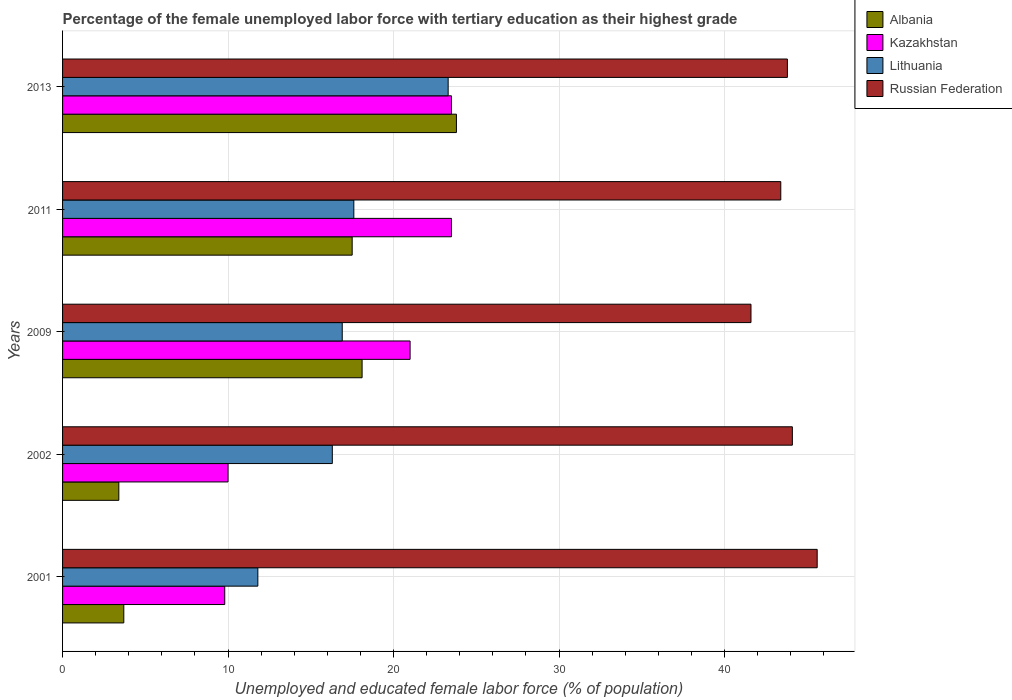How many groups of bars are there?
Offer a terse response. 5. Are the number of bars on each tick of the Y-axis equal?
Keep it short and to the point. Yes. How many bars are there on the 2nd tick from the top?
Provide a short and direct response. 4. In how many cases, is the number of bars for a given year not equal to the number of legend labels?
Your response must be concise. 0. What is the percentage of the unemployed female labor force with tertiary education in Russian Federation in 2002?
Provide a succinct answer. 44.1. Across all years, what is the minimum percentage of the unemployed female labor force with tertiary education in Albania?
Give a very brief answer. 3.4. In which year was the percentage of the unemployed female labor force with tertiary education in Russian Federation maximum?
Provide a succinct answer. 2001. What is the total percentage of the unemployed female labor force with tertiary education in Kazakhstan in the graph?
Offer a very short reply. 87.8. What is the difference between the percentage of the unemployed female labor force with tertiary education in Russian Federation in 2002 and that in 2013?
Offer a very short reply. 0.3. What is the difference between the percentage of the unemployed female labor force with tertiary education in Kazakhstan in 2009 and the percentage of the unemployed female labor force with tertiary education in Russian Federation in 2013?
Offer a very short reply. -22.8. What is the average percentage of the unemployed female labor force with tertiary education in Kazakhstan per year?
Your response must be concise. 17.56. In the year 2002, what is the difference between the percentage of the unemployed female labor force with tertiary education in Kazakhstan and percentage of the unemployed female labor force with tertiary education in Lithuania?
Offer a terse response. -6.3. What is the ratio of the percentage of the unemployed female labor force with tertiary education in Kazakhstan in 2001 to that in 2009?
Make the answer very short. 0.47. Is the difference between the percentage of the unemployed female labor force with tertiary education in Kazakhstan in 2002 and 2011 greater than the difference between the percentage of the unemployed female labor force with tertiary education in Lithuania in 2002 and 2011?
Provide a short and direct response. No. What is the difference between the highest and the second highest percentage of the unemployed female labor force with tertiary education in Albania?
Your answer should be compact. 5.7. What is the difference between the highest and the lowest percentage of the unemployed female labor force with tertiary education in Kazakhstan?
Your response must be concise. 13.7. In how many years, is the percentage of the unemployed female labor force with tertiary education in Lithuania greater than the average percentage of the unemployed female labor force with tertiary education in Lithuania taken over all years?
Provide a succinct answer. 2. Is the sum of the percentage of the unemployed female labor force with tertiary education in Albania in 2002 and 2009 greater than the maximum percentage of the unemployed female labor force with tertiary education in Kazakhstan across all years?
Your response must be concise. No. Is it the case that in every year, the sum of the percentage of the unemployed female labor force with tertiary education in Lithuania and percentage of the unemployed female labor force with tertiary education in Russian Federation is greater than the sum of percentage of the unemployed female labor force with tertiary education in Kazakhstan and percentage of the unemployed female labor force with tertiary education in Albania?
Keep it short and to the point. Yes. What does the 2nd bar from the top in 2002 represents?
Your answer should be compact. Lithuania. What does the 2nd bar from the bottom in 2013 represents?
Give a very brief answer. Kazakhstan. What is the difference between two consecutive major ticks on the X-axis?
Provide a short and direct response. 10. Where does the legend appear in the graph?
Keep it short and to the point. Top right. What is the title of the graph?
Ensure brevity in your answer.  Percentage of the female unemployed labor force with tertiary education as their highest grade. What is the label or title of the X-axis?
Your answer should be compact. Unemployed and educated female labor force (% of population). What is the Unemployed and educated female labor force (% of population) in Albania in 2001?
Your answer should be very brief. 3.7. What is the Unemployed and educated female labor force (% of population) of Kazakhstan in 2001?
Provide a succinct answer. 9.8. What is the Unemployed and educated female labor force (% of population) in Lithuania in 2001?
Offer a terse response. 11.8. What is the Unemployed and educated female labor force (% of population) in Russian Federation in 2001?
Provide a succinct answer. 45.6. What is the Unemployed and educated female labor force (% of population) of Albania in 2002?
Make the answer very short. 3.4. What is the Unemployed and educated female labor force (% of population) of Lithuania in 2002?
Provide a succinct answer. 16.3. What is the Unemployed and educated female labor force (% of population) of Russian Federation in 2002?
Make the answer very short. 44.1. What is the Unemployed and educated female labor force (% of population) in Albania in 2009?
Give a very brief answer. 18.1. What is the Unemployed and educated female labor force (% of population) of Kazakhstan in 2009?
Your response must be concise. 21. What is the Unemployed and educated female labor force (% of population) of Lithuania in 2009?
Your answer should be very brief. 16.9. What is the Unemployed and educated female labor force (% of population) of Russian Federation in 2009?
Provide a short and direct response. 41.6. What is the Unemployed and educated female labor force (% of population) in Albania in 2011?
Your answer should be very brief. 17.5. What is the Unemployed and educated female labor force (% of population) in Lithuania in 2011?
Offer a terse response. 17.6. What is the Unemployed and educated female labor force (% of population) of Russian Federation in 2011?
Provide a succinct answer. 43.4. What is the Unemployed and educated female labor force (% of population) of Albania in 2013?
Ensure brevity in your answer.  23.8. What is the Unemployed and educated female labor force (% of population) of Lithuania in 2013?
Ensure brevity in your answer.  23.3. What is the Unemployed and educated female labor force (% of population) of Russian Federation in 2013?
Your answer should be compact. 43.8. Across all years, what is the maximum Unemployed and educated female labor force (% of population) in Albania?
Offer a very short reply. 23.8. Across all years, what is the maximum Unemployed and educated female labor force (% of population) in Lithuania?
Provide a short and direct response. 23.3. Across all years, what is the maximum Unemployed and educated female labor force (% of population) in Russian Federation?
Offer a terse response. 45.6. Across all years, what is the minimum Unemployed and educated female labor force (% of population) of Albania?
Keep it short and to the point. 3.4. Across all years, what is the minimum Unemployed and educated female labor force (% of population) of Kazakhstan?
Your response must be concise. 9.8. Across all years, what is the minimum Unemployed and educated female labor force (% of population) of Lithuania?
Your response must be concise. 11.8. Across all years, what is the minimum Unemployed and educated female labor force (% of population) in Russian Federation?
Provide a short and direct response. 41.6. What is the total Unemployed and educated female labor force (% of population) in Albania in the graph?
Make the answer very short. 66.5. What is the total Unemployed and educated female labor force (% of population) of Kazakhstan in the graph?
Your answer should be compact. 87.8. What is the total Unemployed and educated female labor force (% of population) of Lithuania in the graph?
Provide a short and direct response. 85.9. What is the total Unemployed and educated female labor force (% of population) of Russian Federation in the graph?
Your response must be concise. 218.5. What is the difference between the Unemployed and educated female labor force (% of population) in Albania in 2001 and that in 2002?
Provide a short and direct response. 0.3. What is the difference between the Unemployed and educated female labor force (% of population) of Kazakhstan in 2001 and that in 2002?
Provide a succinct answer. -0.2. What is the difference between the Unemployed and educated female labor force (% of population) of Albania in 2001 and that in 2009?
Give a very brief answer. -14.4. What is the difference between the Unemployed and educated female labor force (% of population) of Kazakhstan in 2001 and that in 2009?
Keep it short and to the point. -11.2. What is the difference between the Unemployed and educated female labor force (% of population) in Lithuania in 2001 and that in 2009?
Your answer should be very brief. -5.1. What is the difference between the Unemployed and educated female labor force (% of population) in Russian Federation in 2001 and that in 2009?
Make the answer very short. 4. What is the difference between the Unemployed and educated female labor force (% of population) of Kazakhstan in 2001 and that in 2011?
Your response must be concise. -13.7. What is the difference between the Unemployed and educated female labor force (% of population) in Lithuania in 2001 and that in 2011?
Your answer should be compact. -5.8. What is the difference between the Unemployed and educated female labor force (% of population) of Albania in 2001 and that in 2013?
Your answer should be compact. -20.1. What is the difference between the Unemployed and educated female labor force (% of population) of Kazakhstan in 2001 and that in 2013?
Your response must be concise. -13.7. What is the difference between the Unemployed and educated female labor force (% of population) in Lithuania in 2001 and that in 2013?
Your answer should be compact. -11.5. What is the difference between the Unemployed and educated female labor force (% of population) of Albania in 2002 and that in 2009?
Your answer should be very brief. -14.7. What is the difference between the Unemployed and educated female labor force (% of population) in Russian Federation in 2002 and that in 2009?
Ensure brevity in your answer.  2.5. What is the difference between the Unemployed and educated female labor force (% of population) in Albania in 2002 and that in 2011?
Your answer should be very brief. -14.1. What is the difference between the Unemployed and educated female labor force (% of population) in Russian Federation in 2002 and that in 2011?
Your answer should be compact. 0.7. What is the difference between the Unemployed and educated female labor force (% of population) in Albania in 2002 and that in 2013?
Ensure brevity in your answer.  -20.4. What is the difference between the Unemployed and educated female labor force (% of population) in Kazakhstan in 2002 and that in 2013?
Your answer should be compact. -13.5. What is the difference between the Unemployed and educated female labor force (% of population) in Lithuania in 2002 and that in 2013?
Keep it short and to the point. -7. What is the difference between the Unemployed and educated female labor force (% of population) of Albania in 2009 and that in 2011?
Provide a short and direct response. 0.6. What is the difference between the Unemployed and educated female labor force (% of population) in Kazakhstan in 2009 and that in 2011?
Your answer should be compact. -2.5. What is the difference between the Unemployed and educated female labor force (% of population) of Lithuania in 2009 and that in 2011?
Your response must be concise. -0.7. What is the difference between the Unemployed and educated female labor force (% of population) of Albania in 2009 and that in 2013?
Offer a very short reply. -5.7. What is the difference between the Unemployed and educated female labor force (% of population) of Kazakhstan in 2009 and that in 2013?
Ensure brevity in your answer.  -2.5. What is the difference between the Unemployed and educated female labor force (% of population) of Lithuania in 2009 and that in 2013?
Offer a terse response. -6.4. What is the difference between the Unemployed and educated female labor force (% of population) in Russian Federation in 2009 and that in 2013?
Offer a terse response. -2.2. What is the difference between the Unemployed and educated female labor force (% of population) in Russian Federation in 2011 and that in 2013?
Keep it short and to the point. -0.4. What is the difference between the Unemployed and educated female labor force (% of population) in Albania in 2001 and the Unemployed and educated female labor force (% of population) in Russian Federation in 2002?
Ensure brevity in your answer.  -40.4. What is the difference between the Unemployed and educated female labor force (% of population) in Kazakhstan in 2001 and the Unemployed and educated female labor force (% of population) in Russian Federation in 2002?
Provide a short and direct response. -34.3. What is the difference between the Unemployed and educated female labor force (% of population) in Lithuania in 2001 and the Unemployed and educated female labor force (% of population) in Russian Federation in 2002?
Ensure brevity in your answer.  -32.3. What is the difference between the Unemployed and educated female labor force (% of population) in Albania in 2001 and the Unemployed and educated female labor force (% of population) in Kazakhstan in 2009?
Keep it short and to the point. -17.3. What is the difference between the Unemployed and educated female labor force (% of population) of Albania in 2001 and the Unemployed and educated female labor force (% of population) of Lithuania in 2009?
Keep it short and to the point. -13.2. What is the difference between the Unemployed and educated female labor force (% of population) of Albania in 2001 and the Unemployed and educated female labor force (% of population) of Russian Federation in 2009?
Give a very brief answer. -37.9. What is the difference between the Unemployed and educated female labor force (% of population) in Kazakhstan in 2001 and the Unemployed and educated female labor force (% of population) in Russian Federation in 2009?
Your response must be concise. -31.8. What is the difference between the Unemployed and educated female labor force (% of population) in Lithuania in 2001 and the Unemployed and educated female labor force (% of population) in Russian Federation in 2009?
Give a very brief answer. -29.8. What is the difference between the Unemployed and educated female labor force (% of population) of Albania in 2001 and the Unemployed and educated female labor force (% of population) of Kazakhstan in 2011?
Your response must be concise. -19.8. What is the difference between the Unemployed and educated female labor force (% of population) of Albania in 2001 and the Unemployed and educated female labor force (% of population) of Russian Federation in 2011?
Offer a very short reply. -39.7. What is the difference between the Unemployed and educated female labor force (% of population) in Kazakhstan in 2001 and the Unemployed and educated female labor force (% of population) in Russian Federation in 2011?
Your response must be concise. -33.6. What is the difference between the Unemployed and educated female labor force (% of population) in Lithuania in 2001 and the Unemployed and educated female labor force (% of population) in Russian Federation in 2011?
Your answer should be compact. -31.6. What is the difference between the Unemployed and educated female labor force (% of population) in Albania in 2001 and the Unemployed and educated female labor force (% of population) in Kazakhstan in 2013?
Give a very brief answer. -19.8. What is the difference between the Unemployed and educated female labor force (% of population) in Albania in 2001 and the Unemployed and educated female labor force (% of population) in Lithuania in 2013?
Ensure brevity in your answer.  -19.6. What is the difference between the Unemployed and educated female labor force (% of population) in Albania in 2001 and the Unemployed and educated female labor force (% of population) in Russian Federation in 2013?
Ensure brevity in your answer.  -40.1. What is the difference between the Unemployed and educated female labor force (% of population) in Kazakhstan in 2001 and the Unemployed and educated female labor force (% of population) in Lithuania in 2013?
Your answer should be compact. -13.5. What is the difference between the Unemployed and educated female labor force (% of population) in Kazakhstan in 2001 and the Unemployed and educated female labor force (% of population) in Russian Federation in 2013?
Provide a succinct answer. -34. What is the difference between the Unemployed and educated female labor force (% of population) in Lithuania in 2001 and the Unemployed and educated female labor force (% of population) in Russian Federation in 2013?
Provide a short and direct response. -32. What is the difference between the Unemployed and educated female labor force (% of population) of Albania in 2002 and the Unemployed and educated female labor force (% of population) of Kazakhstan in 2009?
Provide a succinct answer. -17.6. What is the difference between the Unemployed and educated female labor force (% of population) of Albania in 2002 and the Unemployed and educated female labor force (% of population) of Lithuania in 2009?
Offer a very short reply. -13.5. What is the difference between the Unemployed and educated female labor force (% of population) in Albania in 2002 and the Unemployed and educated female labor force (% of population) in Russian Federation in 2009?
Your answer should be compact. -38.2. What is the difference between the Unemployed and educated female labor force (% of population) in Kazakhstan in 2002 and the Unemployed and educated female labor force (% of population) in Russian Federation in 2009?
Offer a very short reply. -31.6. What is the difference between the Unemployed and educated female labor force (% of population) of Lithuania in 2002 and the Unemployed and educated female labor force (% of population) of Russian Federation in 2009?
Provide a succinct answer. -25.3. What is the difference between the Unemployed and educated female labor force (% of population) in Albania in 2002 and the Unemployed and educated female labor force (% of population) in Kazakhstan in 2011?
Keep it short and to the point. -20.1. What is the difference between the Unemployed and educated female labor force (% of population) of Albania in 2002 and the Unemployed and educated female labor force (% of population) of Lithuania in 2011?
Your answer should be compact. -14.2. What is the difference between the Unemployed and educated female labor force (% of population) of Kazakhstan in 2002 and the Unemployed and educated female labor force (% of population) of Lithuania in 2011?
Ensure brevity in your answer.  -7.6. What is the difference between the Unemployed and educated female labor force (% of population) of Kazakhstan in 2002 and the Unemployed and educated female labor force (% of population) of Russian Federation in 2011?
Give a very brief answer. -33.4. What is the difference between the Unemployed and educated female labor force (% of population) in Lithuania in 2002 and the Unemployed and educated female labor force (% of population) in Russian Federation in 2011?
Your answer should be very brief. -27.1. What is the difference between the Unemployed and educated female labor force (% of population) in Albania in 2002 and the Unemployed and educated female labor force (% of population) in Kazakhstan in 2013?
Give a very brief answer. -20.1. What is the difference between the Unemployed and educated female labor force (% of population) in Albania in 2002 and the Unemployed and educated female labor force (% of population) in Lithuania in 2013?
Your answer should be compact. -19.9. What is the difference between the Unemployed and educated female labor force (% of population) of Albania in 2002 and the Unemployed and educated female labor force (% of population) of Russian Federation in 2013?
Keep it short and to the point. -40.4. What is the difference between the Unemployed and educated female labor force (% of population) in Kazakhstan in 2002 and the Unemployed and educated female labor force (% of population) in Russian Federation in 2013?
Make the answer very short. -33.8. What is the difference between the Unemployed and educated female labor force (% of population) in Lithuania in 2002 and the Unemployed and educated female labor force (% of population) in Russian Federation in 2013?
Make the answer very short. -27.5. What is the difference between the Unemployed and educated female labor force (% of population) of Albania in 2009 and the Unemployed and educated female labor force (% of population) of Kazakhstan in 2011?
Give a very brief answer. -5.4. What is the difference between the Unemployed and educated female labor force (% of population) in Albania in 2009 and the Unemployed and educated female labor force (% of population) in Russian Federation in 2011?
Provide a short and direct response. -25.3. What is the difference between the Unemployed and educated female labor force (% of population) in Kazakhstan in 2009 and the Unemployed and educated female labor force (% of population) in Lithuania in 2011?
Provide a short and direct response. 3.4. What is the difference between the Unemployed and educated female labor force (% of population) of Kazakhstan in 2009 and the Unemployed and educated female labor force (% of population) of Russian Federation in 2011?
Keep it short and to the point. -22.4. What is the difference between the Unemployed and educated female labor force (% of population) of Lithuania in 2009 and the Unemployed and educated female labor force (% of population) of Russian Federation in 2011?
Provide a succinct answer. -26.5. What is the difference between the Unemployed and educated female labor force (% of population) of Albania in 2009 and the Unemployed and educated female labor force (% of population) of Kazakhstan in 2013?
Your answer should be compact. -5.4. What is the difference between the Unemployed and educated female labor force (% of population) of Albania in 2009 and the Unemployed and educated female labor force (% of population) of Russian Federation in 2013?
Provide a succinct answer. -25.7. What is the difference between the Unemployed and educated female labor force (% of population) in Kazakhstan in 2009 and the Unemployed and educated female labor force (% of population) in Russian Federation in 2013?
Make the answer very short. -22.8. What is the difference between the Unemployed and educated female labor force (% of population) in Lithuania in 2009 and the Unemployed and educated female labor force (% of population) in Russian Federation in 2013?
Your answer should be compact. -26.9. What is the difference between the Unemployed and educated female labor force (% of population) in Albania in 2011 and the Unemployed and educated female labor force (% of population) in Lithuania in 2013?
Your answer should be compact. -5.8. What is the difference between the Unemployed and educated female labor force (% of population) in Albania in 2011 and the Unemployed and educated female labor force (% of population) in Russian Federation in 2013?
Provide a succinct answer. -26.3. What is the difference between the Unemployed and educated female labor force (% of population) in Kazakhstan in 2011 and the Unemployed and educated female labor force (% of population) in Russian Federation in 2013?
Give a very brief answer. -20.3. What is the difference between the Unemployed and educated female labor force (% of population) of Lithuania in 2011 and the Unemployed and educated female labor force (% of population) of Russian Federation in 2013?
Give a very brief answer. -26.2. What is the average Unemployed and educated female labor force (% of population) in Kazakhstan per year?
Provide a succinct answer. 17.56. What is the average Unemployed and educated female labor force (% of population) in Lithuania per year?
Keep it short and to the point. 17.18. What is the average Unemployed and educated female labor force (% of population) in Russian Federation per year?
Ensure brevity in your answer.  43.7. In the year 2001, what is the difference between the Unemployed and educated female labor force (% of population) of Albania and Unemployed and educated female labor force (% of population) of Lithuania?
Provide a short and direct response. -8.1. In the year 2001, what is the difference between the Unemployed and educated female labor force (% of population) of Albania and Unemployed and educated female labor force (% of population) of Russian Federation?
Your answer should be very brief. -41.9. In the year 2001, what is the difference between the Unemployed and educated female labor force (% of population) in Kazakhstan and Unemployed and educated female labor force (% of population) in Russian Federation?
Your answer should be very brief. -35.8. In the year 2001, what is the difference between the Unemployed and educated female labor force (% of population) of Lithuania and Unemployed and educated female labor force (% of population) of Russian Federation?
Your answer should be very brief. -33.8. In the year 2002, what is the difference between the Unemployed and educated female labor force (% of population) of Albania and Unemployed and educated female labor force (% of population) of Russian Federation?
Ensure brevity in your answer.  -40.7. In the year 2002, what is the difference between the Unemployed and educated female labor force (% of population) of Kazakhstan and Unemployed and educated female labor force (% of population) of Russian Federation?
Make the answer very short. -34.1. In the year 2002, what is the difference between the Unemployed and educated female labor force (% of population) of Lithuania and Unemployed and educated female labor force (% of population) of Russian Federation?
Your answer should be very brief. -27.8. In the year 2009, what is the difference between the Unemployed and educated female labor force (% of population) of Albania and Unemployed and educated female labor force (% of population) of Kazakhstan?
Offer a very short reply. -2.9. In the year 2009, what is the difference between the Unemployed and educated female labor force (% of population) of Albania and Unemployed and educated female labor force (% of population) of Lithuania?
Your answer should be very brief. 1.2. In the year 2009, what is the difference between the Unemployed and educated female labor force (% of population) of Albania and Unemployed and educated female labor force (% of population) of Russian Federation?
Your response must be concise. -23.5. In the year 2009, what is the difference between the Unemployed and educated female labor force (% of population) of Kazakhstan and Unemployed and educated female labor force (% of population) of Russian Federation?
Your answer should be very brief. -20.6. In the year 2009, what is the difference between the Unemployed and educated female labor force (% of population) of Lithuania and Unemployed and educated female labor force (% of population) of Russian Federation?
Offer a terse response. -24.7. In the year 2011, what is the difference between the Unemployed and educated female labor force (% of population) of Albania and Unemployed and educated female labor force (% of population) of Kazakhstan?
Offer a very short reply. -6. In the year 2011, what is the difference between the Unemployed and educated female labor force (% of population) in Albania and Unemployed and educated female labor force (% of population) in Russian Federation?
Keep it short and to the point. -25.9. In the year 2011, what is the difference between the Unemployed and educated female labor force (% of population) in Kazakhstan and Unemployed and educated female labor force (% of population) in Lithuania?
Provide a succinct answer. 5.9. In the year 2011, what is the difference between the Unemployed and educated female labor force (% of population) in Kazakhstan and Unemployed and educated female labor force (% of population) in Russian Federation?
Your answer should be compact. -19.9. In the year 2011, what is the difference between the Unemployed and educated female labor force (% of population) of Lithuania and Unemployed and educated female labor force (% of population) of Russian Federation?
Keep it short and to the point. -25.8. In the year 2013, what is the difference between the Unemployed and educated female labor force (% of population) in Kazakhstan and Unemployed and educated female labor force (% of population) in Lithuania?
Offer a very short reply. 0.2. In the year 2013, what is the difference between the Unemployed and educated female labor force (% of population) in Kazakhstan and Unemployed and educated female labor force (% of population) in Russian Federation?
Give a very brief answer. -20.3. In the year 2013, what is the difference between the Unemployed and educated female labor force (% of population) in Lithuania and Unemployed and educated female labor force (% of population) in Russian Federation?
Ensure brevity in your answer.  -20.5. What is the ratio of the Unemployed and educated female labor force (% of population) in Albania in 2001 to that in 2002?
Offer a terse response. 1.09. What is the ratio of the Unemployed and educated female labor force (% of population) in Kazakhstan in 2001 to that in 2002?
Your answer should be very brief. 0.98. What is the ratio of the Unemployed and educated female labor force (% of population) in Lithuania in 2001 to that in 2002?
Make the answer very short. 0.72. What is the ratio of the Unemployed and educated female labor force (% of population) in Russian Federation in 2001 to that in 2002?
Offer a terse response. 1.03. What is the ratio of the Unemployed and educated female labor force (% of population) of Albania in 2001 to that in 2009?
Keep it short and to the point. 0.2. What is the ratio of the Unemployed and educated female labor force (% of population) of Kazakhstan in 2001 to that in 2009?
Your response must be concise. 0.47. What is the ratio of the Unemployed and educated female labor force (% of population) of Lithuania in 2001 to that in 2009?
Ensure brevity in your answer.  0.7. What is the ratio of the Unemployed and educated female labor force (% of population) in Russian Federation in 2001 to that in 2009?
Provide a short and direct response. 1.1. What is the ratio of the Unemployed and educated female labor force (% of population) of Albania in 2001 to that in 2011?
Your response must be concise. 0.21. What is the ratio of the Unemployed and educated female labor force (% of population) of Kazakhstan in 2001 to that in 2011?
Keep it short and to the point. 0.42. What is the ratio of the Unemployed and educated female labor force (% of population) in Lithuania in 2001 to that in 2011?
Give a very brief answer. 0.67. What is the ratio of the Unemployed and educated female labor force (% of population) of Russian Federation in 2001 to that in 2011?
Keep it short and to the point. 1.05. What is the ratio of the Unemployed and educated female labor force (% of population) of Albania in 2001 to that in 2013?
Offer a terse response. 0.16. What is the ratio of the Unemployed and educated female labor force (% of population) in Kazakhstan in 2001 to that in 2013?
Make the answer very short. 0.42. What is the ratio of the Unemployed and educated female labor force (% of population) in Lithuania in 2001 to that in 2013?
Provide a short and direct response. 0.51. What is the ratio of the Unemployed and educated female labor force (% of population) in Russian Federation in 2001 to that in 2013?
Your answer should be very brief. 1.04. What is the ratio of the Unemployed and educated female labor force (% of population) of Albania in 2002 to that in 2009?
Your response must be concise. 0.19. What is the ratio of the Unemployed and educated female labor force (% of population) in Kazakhstan in 2002 to that in 2009?
Make the answer very short. 0.48. What is the ratio of the Unemployed and educated female labor force (% of population) in Lithuania in 2002 to that in 2009?
Offer a very short reply. 0.96. What is the ratio of the Unemployed and educated female labor force (% of population) of Russian Federation in 2002 to that in 2009?
Make the answer very short. 1.06. What is the ratio of the Unemployed and educated female labor force (% of population) in Albania in 2002 to that in 2011?
Keep it short and to the point. 0.19. What is the ratio of the Unemployed and educated female labor force (% of population) of Kazakhstan in 2002 to that in 2011?
Offer a terse response. 0.43. What is the ratio of the Unemployed and educated female labor force (% of population) of Lithuania in 2002 to that in 2011?
Ensure brevity in your answer.  0.93. What is the ratio of the Unemployed and educated female labor force (% of population) in Russian Federation in 2002 to that in 2011?
Provide a short and direct response. 1.02. What is the ratio of the Unemployed and educated female labor force (% of population) of Albania in 2002 to that in 2013?
Provide a succinct answer. 0.14. What is the ratio of the Unemployed and educated female labor force (% of population) of Kazakhstan in 2002 to that in 2013?
Provide a succinct answer. 0.43. What is the ratio of the Unemployed and educated female labor force (% of population) of Lithuania in 2002 to that in 2013?
Give a very brief answer. 0.7. What is the ratio of the Unemployed and educated female labor force (% of population) in Russian Federation in 2002 to that in 2013?
Offer a terse response. 1.01. What is the ratio of the Unemployed and educated female labor force (% of population) in Albania in 2009 to that in 2011?
Provide a short and direct response. 1.03. What is the ratio of the Unemployed and educated female labor force (% of population) of Kazakhstan in 2009 to that in 2011?
Keep it short and to the point. 0.89. What is the ratio of the Unemployed and educated female labor force (% of population) of Lithuania in 2009 to that in 2011?
Provide a short and direct response. 0.96. What is the ratio of the Unemployed and educated female labor force (% of population) in Russian Federation in 2009 to that in 2011?
Offer a very short reply. 0.96. What is the ratio of the Unemployed and educated female labor force (% of population) of Albania in 2009 to that in 2013?
Keep it short and to the point. 0.76. What is the ratio of the Unemployed and educated female labor force (% of population) of Kazakhstan in 2009 to that in 2013?
Offer a very short reply. 0.89. What is the ratio of the Unemployed and educated female labor force (% of population) in Lithuania in 2009 to that in 2013?
Your answer should be compact. 0.73. What is the ratio of the Unemployed and educated female labor force (% of population) of Russian Federation in 2009 to that in 2013?
Provide a short and direct response. 0.95. What is the ratio of the Unemployed and educated female labor force (% of population) in Albania in 2011 to that in 2013?
Offer a terse response. 0.74. What is the ratio of the Unemployed and educated female labor force (% of population) in Lithuania in 2011 to that in 2013?
Your answer should be compact. 0.76. What is the ratio of the Unemployed and educated female labor force (% of population) in Russian Federation in 2011 to that in 2013?
Provide a short and direct response. 0.99. What is the difference between the highest and the second highest Unemployed and educated female labor force (% of population) of Kazakhstan?
Offer a terse response. 0. What is the difference between the highest and the second highest Unemployed and educated female labor force (% of population) of Lithuania?
Provide a short and direct response. 5.7. What is the difference between the highest and the lowest Unemployed and educated female labor force (% of population) in Albania?
Your answer should be very brief. 20.4. 